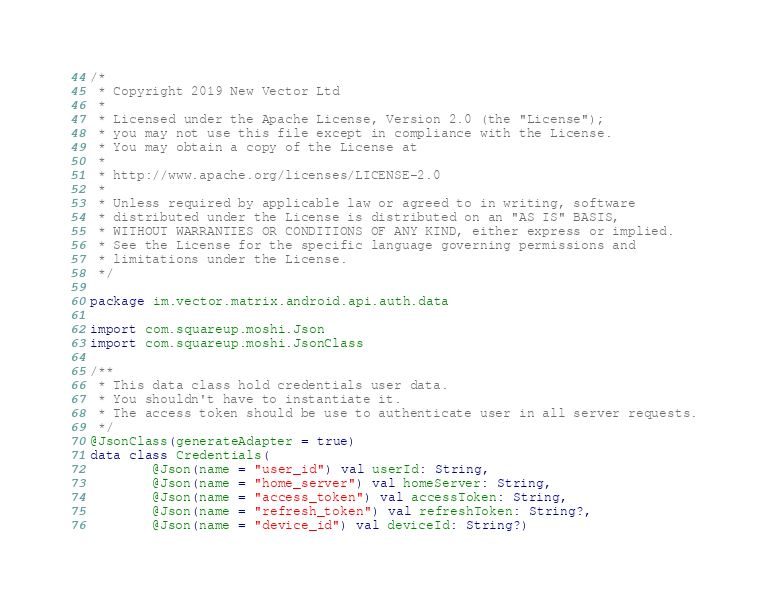Convert code to text. <code><loc_0><loc_0><loc_500><loc_500><_Kotlin_>/*
 * Copyright 2019 New Vector Ltd
 *
 * Licensed under the Apache License, Version 2.0 (the "License");
 * you may not use this file except in compliance with the License.
 * You may obtain a copy of the License at
 *
 * http://www.apache.org/licenses/LICENSE-2.0
 *
 * Unless required by applicable law or agreed to in writing, software
 * distributed under the License is distributed on an "AS IS" BASIS,
 * WITHOUT WARRANTIES OR CONDITIONS OF ANY KIND, either express or implied.
 * See the License for the specific language governing permissions and
 * limitations under the License.
 */

package im.vector.matrix.android.api.auth.data

import com.squareup.moshi.Json
import com.squareup.moshi.JsonClass

/**
 * This data class hold credentials user data.
 * You shouldn't have to instantiate it.
 * The access token should be use to authenticate user in all server requests.
 */
@JsonClass(generateAdapter = true)
data class Credentials(
        @Json(name = "user_id") val userId: String,
        @Json(name = "home_server") val homeServer: String,
        @Json(name = "access_token") val accessToken: String,
        @Json(name = "refresh_token") val refreshToken: String?,
        @Json(name = "device_id") val deviceId: String?)
</code> 